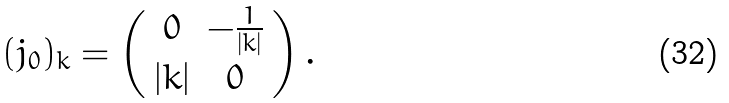<formula> <loc_0><loc_0><loc_500><loc_500>( j _ { 0 } ) _ { k } = \left ( \begin{array} { c c } 0 & - \frac { 1 } { | k | } \\ | k | & 0 \end{array} \right ) .</formula> 